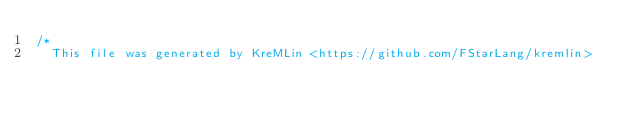<code> <loc_0><loc_0><loc_500><loc_500><_C_>/* 
  This file was generated by KreMLin <https://github.com/FStarLang/kremlin></code> 